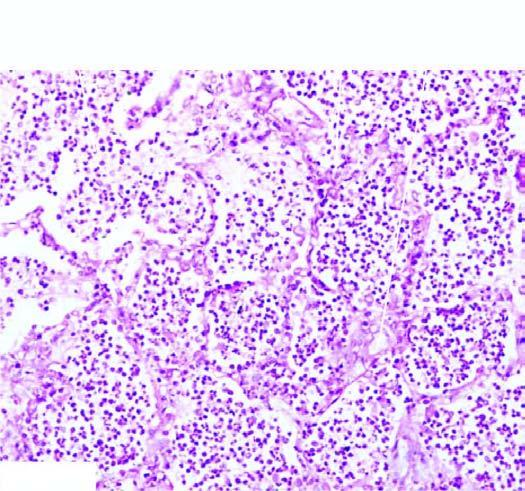re inbox filled with cellular exudates composed of neutrophils admixed with some red cells?
Answer the question using a single word or phrase. No 